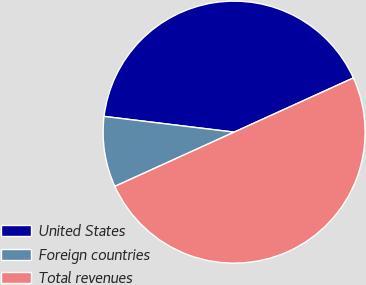Convert chart. <chart><loc_0><loc_0><loc_500><loc_500><pie_chart><fcel>United States<fcel>Foreign countries<fcel>Total revenues<nl><fcel>41.29%<fcel>8.71%<fcel>50.0%<nl></chart> 